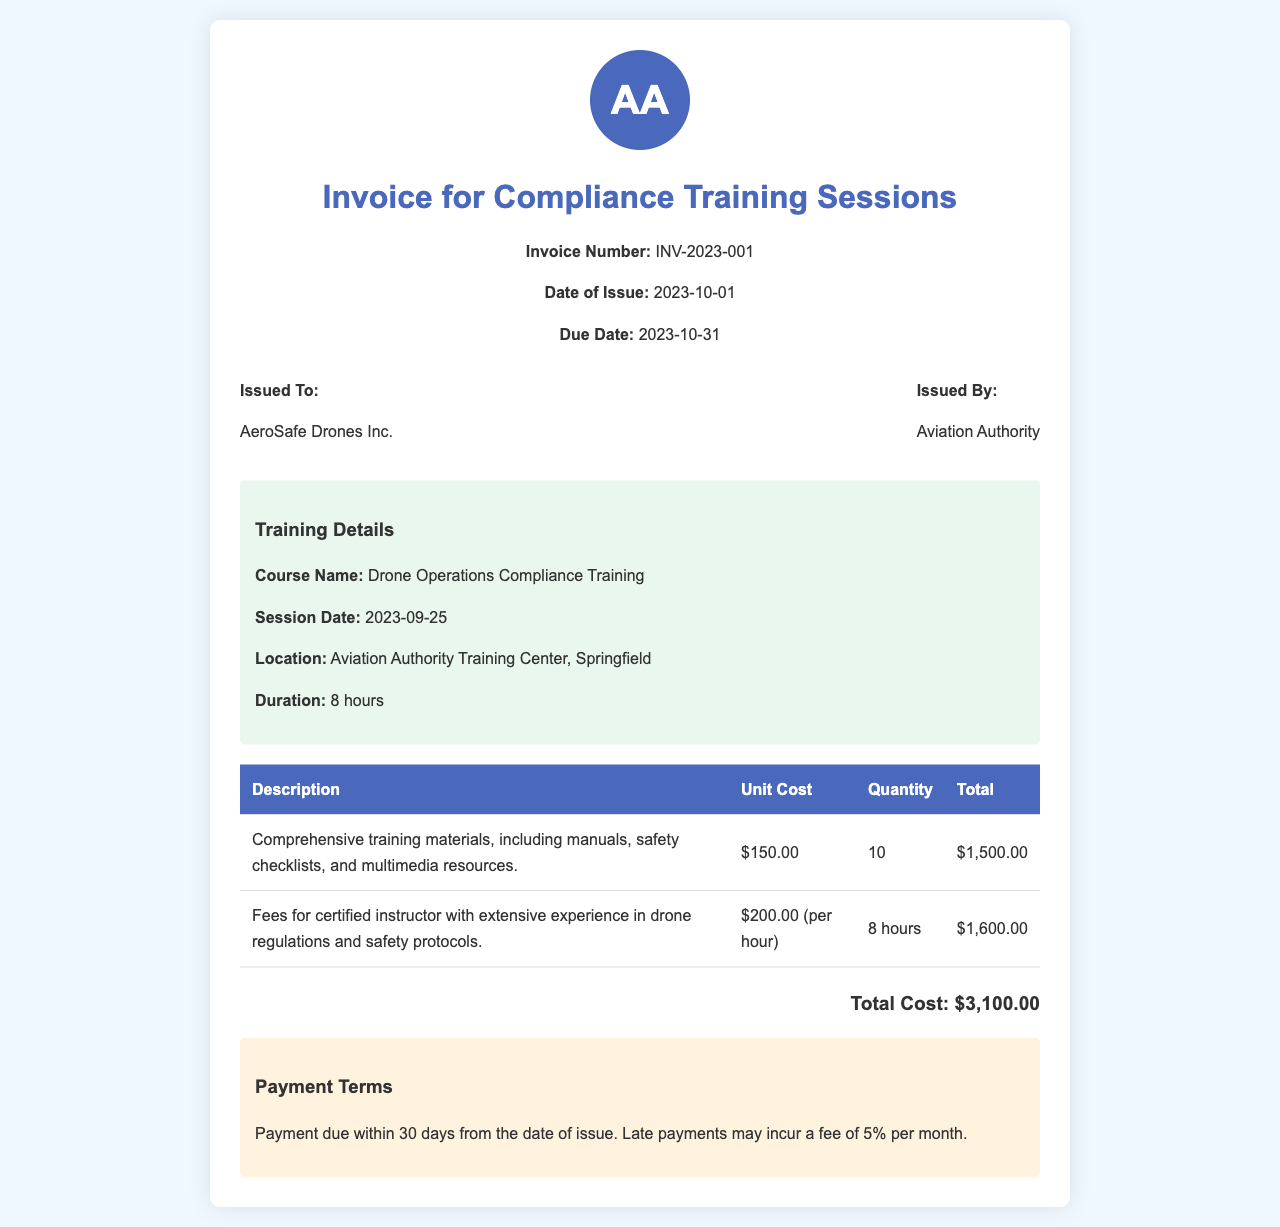What is the invoice number? The invoice number is mentioned in the header of the document as a unique identifier.
Answer: INV-2023-001 What is the total cost? The total cost is calculated from the training materials and instructor fees combined stated in the invoice.
Answer: $3,100.00 Who is the invoice issued to? The recipient of the invoice, as stated in the invoice details section, identifies the entity receiving the services.
Answer: AeroSafe Drones Inc What is the session date of the training? The date when the training session took place is specified in the training details section.
Answer: 2023-09-25 What is the unit cost of the training materials? The cost associated with each unit of training materials is indicated in the invoice table.
Answer: $150.00 What payment term is specified for late payments? The document specifies the consequences of late payments, clarifying the additional fee that may apply.
Answer: 5% per month How many hours of training were provided? The number of hours for which the training session was conducted is provided in the training details.
Answer: 8 hours What is the issued by entity? The organization or authority that issued the invoice is identified in the invoice details section.
Answer: Aviation Authority 